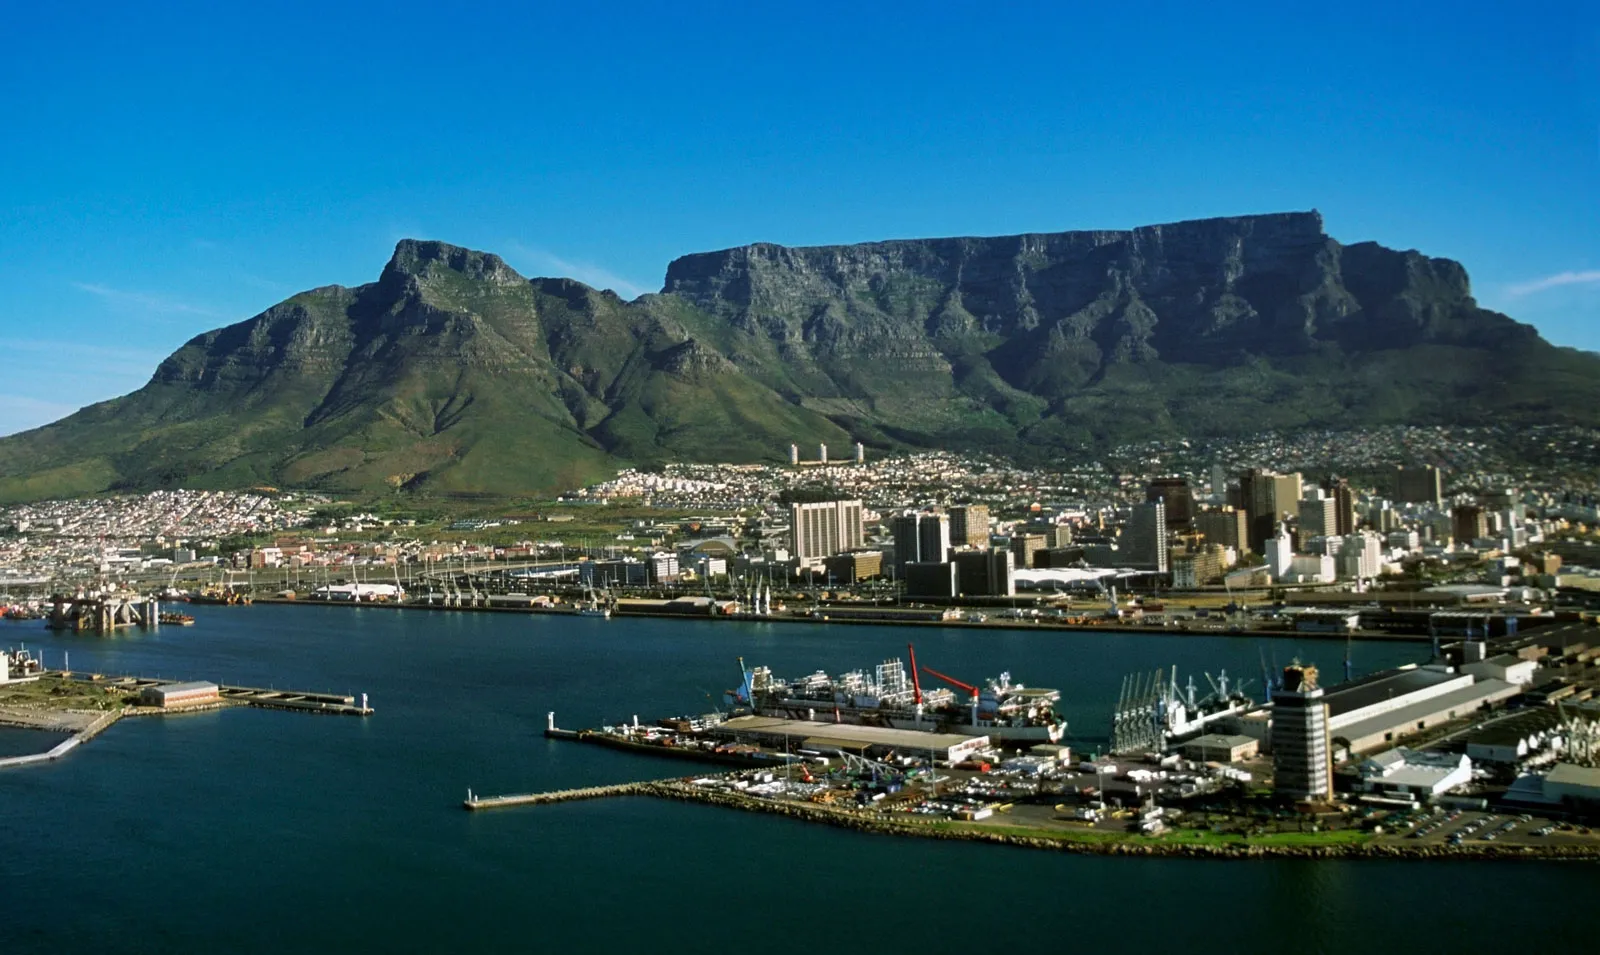What are the key elements in this picture?
 The image captures the majestic Table Mountain, a prominent landmark in Cape Town, South Africa. The mountain, known for its flat top, is bathed in a rich, dark green hue, contrasting beautifully with the bright blue sky above. The perspective of the image is from a distance, providing a panoramic view of the cityscape below the mountain. The city is a blend of white and beige buildings, creating a harmonious palette with the natural colors of the mountain and sky. In the foreground, a harbor bustles with activity, with ships dotting the waters, adding a dynamic element to the otherwise serene landscape. The image is a testament to the coexistence of nature and urban life, each enhancing the beauty of the other. 